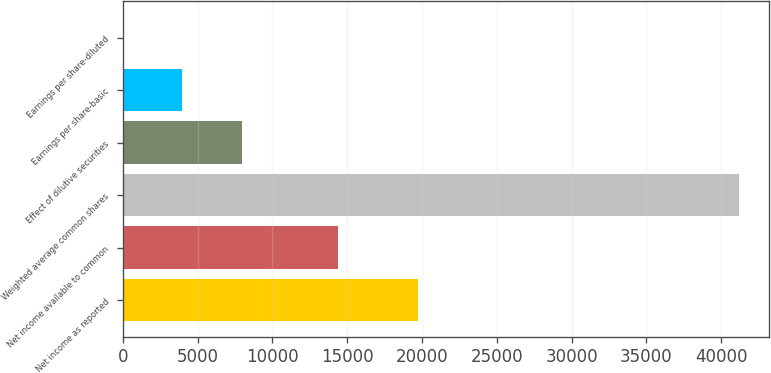<chart> <loc_0><loc_0><loc_500><loc_500><bar_chart><fcel>Net income as reported<fcel>Net income available to common<fcel>Weighted average common shares<fcel>Effect of dilutive securities<fcel>Earnings per share-basic<fcel>Earnings per share-diluted<nl><fcel>19719<fcel>14412<fcel>41167.6<fcel>7937.48<fcel>3968.92<fcel>0.36<nl></chart> 